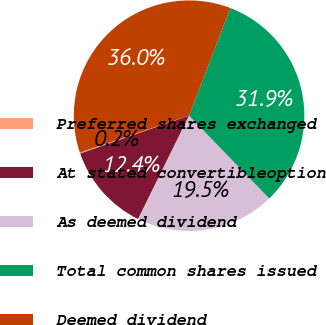Convert chart to OTSL. <chart><loc_0><loc_0><loc_500><loc_500><pie_chart><fcel>Preferred shares exchanged<fcel>At stated convertibleoption<fcel>As deemed dividend<fcel>Total common shares issued<fcel>Deemed dividend<nl><fcel>0.15%<fcel>12.39%<fcel>19.53%<fcel>31.92%<fcel>36.01%<nl></chart> 